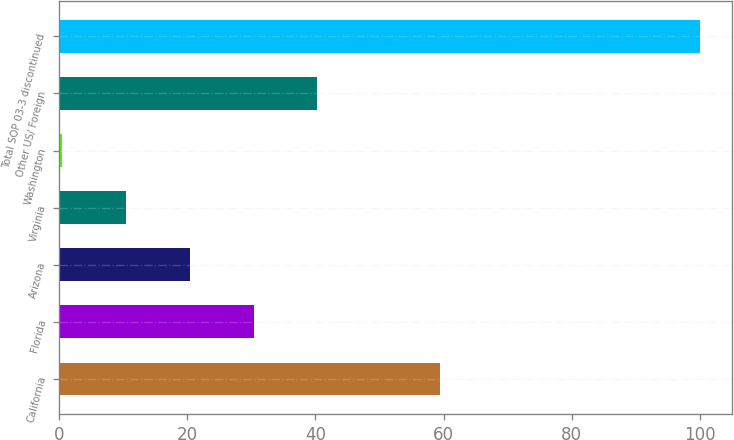Convert chart. <chart><loc_0><loc_0><loc_500><loc_500><bar_chart><fcel>California<fcel>Florida<fcel>Arizona<fcel>Virginia<fcel>Washington<fcel>Other US/ Foreign<fcel>Total SOP 03-3 discontinued<nl><fcel>59.4<fcel>30.35<fcel>20.4<fcel>10.45<fcel>0.5<fcel>40.3<fcel>100<nl></chart> 